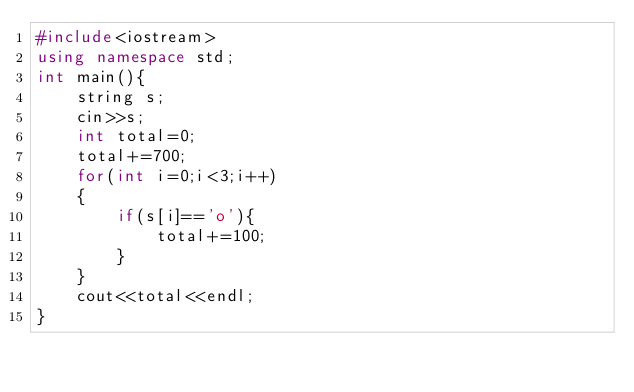<code> <loc_0><loc_0><loc_500><loc_500><_C++_>#include<iostream>
using namespace std;
int main(){
    string s;
    cin>>s;
    int total=0;
    total+=700;
    for(int i=0;i<3;i++)
    {
        if(s[i]=='o'){
            total+=100;
        }
    }
    cout<<total<<endl;
}</code> 